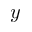<formula> <loc_0><loc_0><loc_500><loc_500>y</formula> 